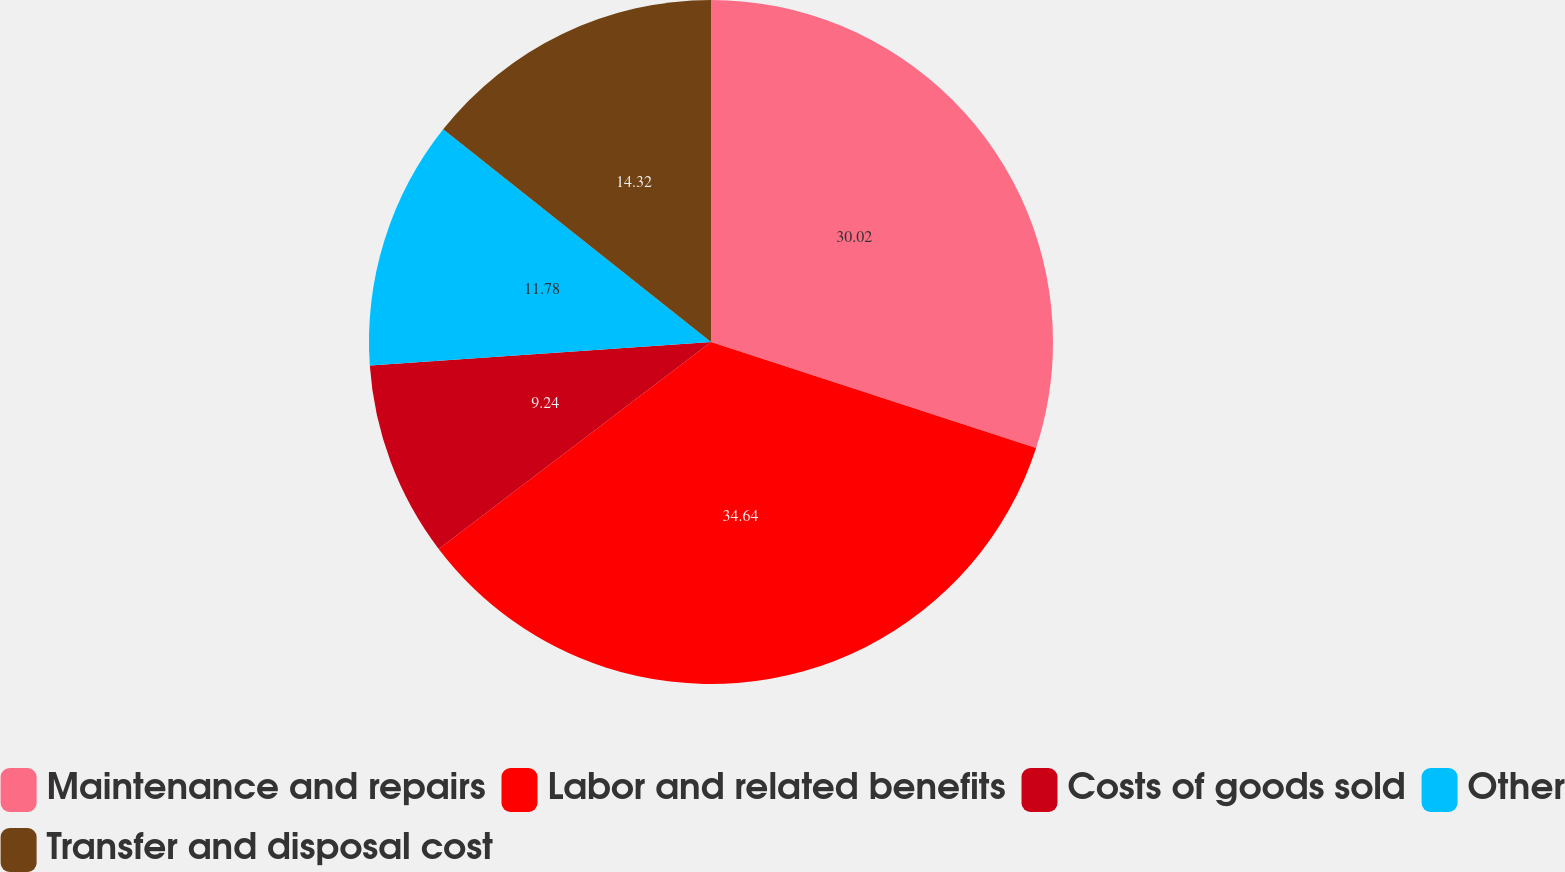Convert chart to OTSL. <chart><loc_0><loc_0><loc_500><loc_500><pie_chart><fcel>Maintenance and repairs<fcel>Labor and related benefits<fcel>Costs of goods sold<fcel>Other<fcel>Transfer and disposal cost<nl><fcel>30.02%<fcel>34.64%<fcel>9.24%<fcel>11.78%<fcel>14.32%<nl></chart> 